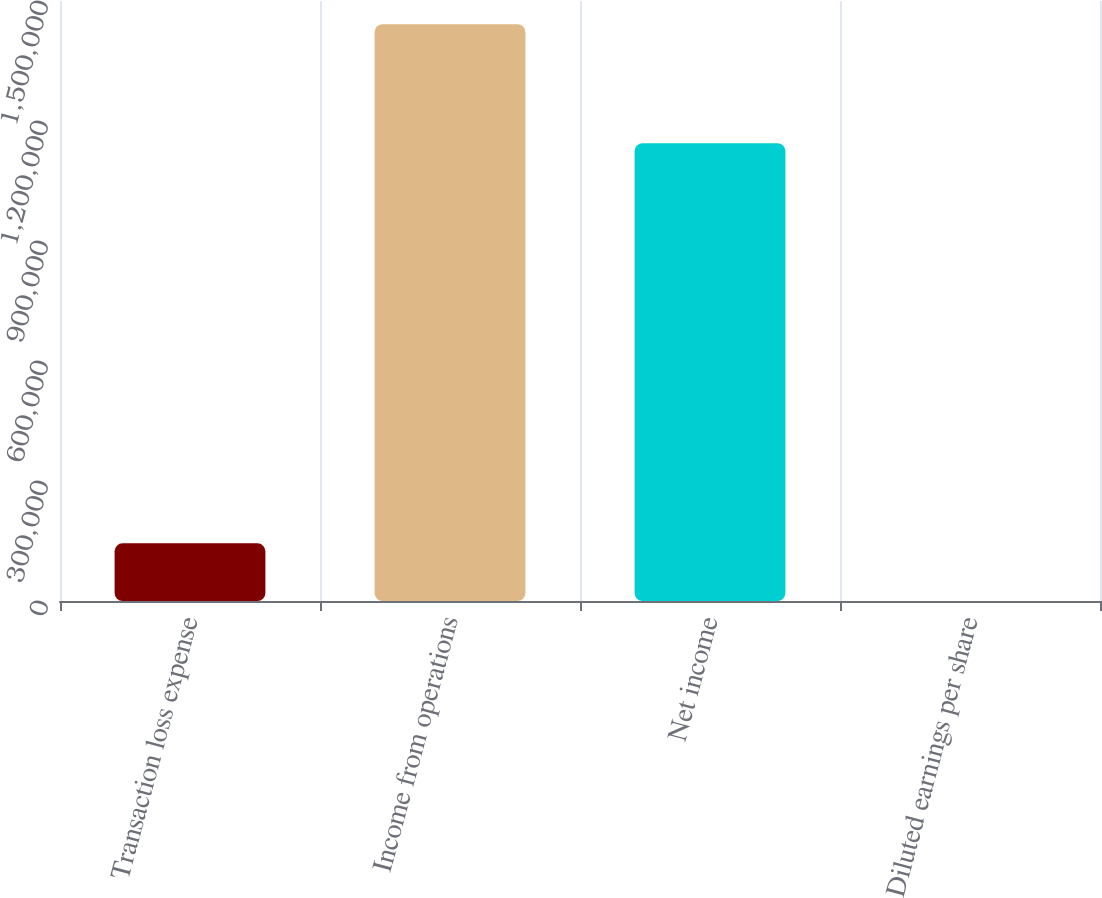<chart> <loc_0><loc_0><loc_500><loc_500><bar_chart><fcel>Transaction loss expense<fcel>Income from operations<fcel>Net income<fcel>Diluted earnings per share<nl><fcel>144184<fcel>1.44183e+06<fcel>1.14452e+06<fcel>0.8<nl></chart> 